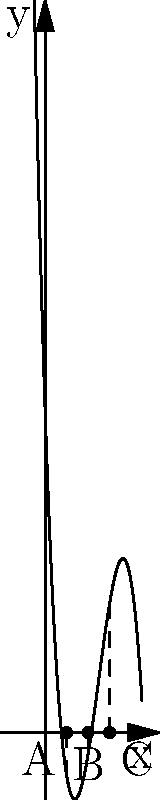As an independent label owner, you're organizing a music festival and want to optimize ticket pricing. The profit function (in thousands of dollars) for ticket sales is modeled by the polynomial $P(x) = -0.5x^3 + 7.5x^2 - 30x + 30$, where $x$ is the ticket price in tens of dollars. The graph of this function is shown above, with roots at points A, B, and C.

What is the optimal ticket price range to maximize profit, and what is the maximum profit within this range? To solve this problem, we'll follow these steps:

1) The roots of the polynomial (x-intercepts) represent the break-even points where profit is zero. These are at $x = 2$, $x = 4$, and $x = 6$.

2) The optimal price range will be between two of these roots, where the function is positive (above the x-axis).

3) We can see from the graph that the function is positive between points A and C, i.e., when $x$ is between 2 and 6.

4) This means the optimal ticket price range is $20 to $60.

5) To find the maximum profit within this range, we need to find the vertex of the parabola-like section between A and C.

6) The vertex occurs at the midpoint between A and C, which is at $x = 4$ (point B).

7) To calculate the maximum profit, we evaluate $P(4)$:

   $P(4) = -0.5(4)^3 + 7.5(4)^2 - 30(4) + 30$
         $= -32 + 120 - 120 + 30$
         $= -2 + 30$
         $= 28$

8) Therefore, the maximum profit is $28,000 when the ticket price is $40.
Answer: Optimal price range: $20-$60; Maximum profit: $28,000 at $40 